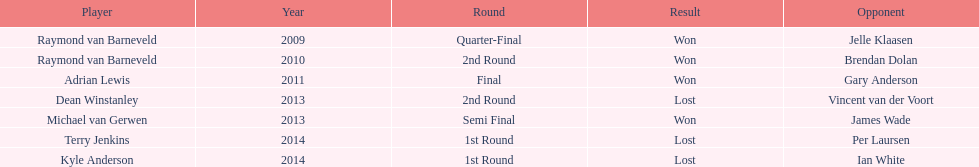Who emerged victorious in the inaugural world darts championship? Raymond van Barneveld. 